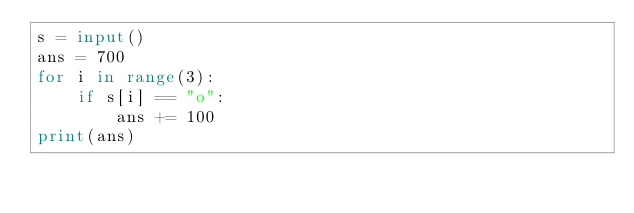<code> <loc_0><loc_0><loc_500><loc_500><_Python_>s = input()
ans = 700
for i in range(3):
    if s[i] == "o":
        ans += 100
print(ans)</code> 